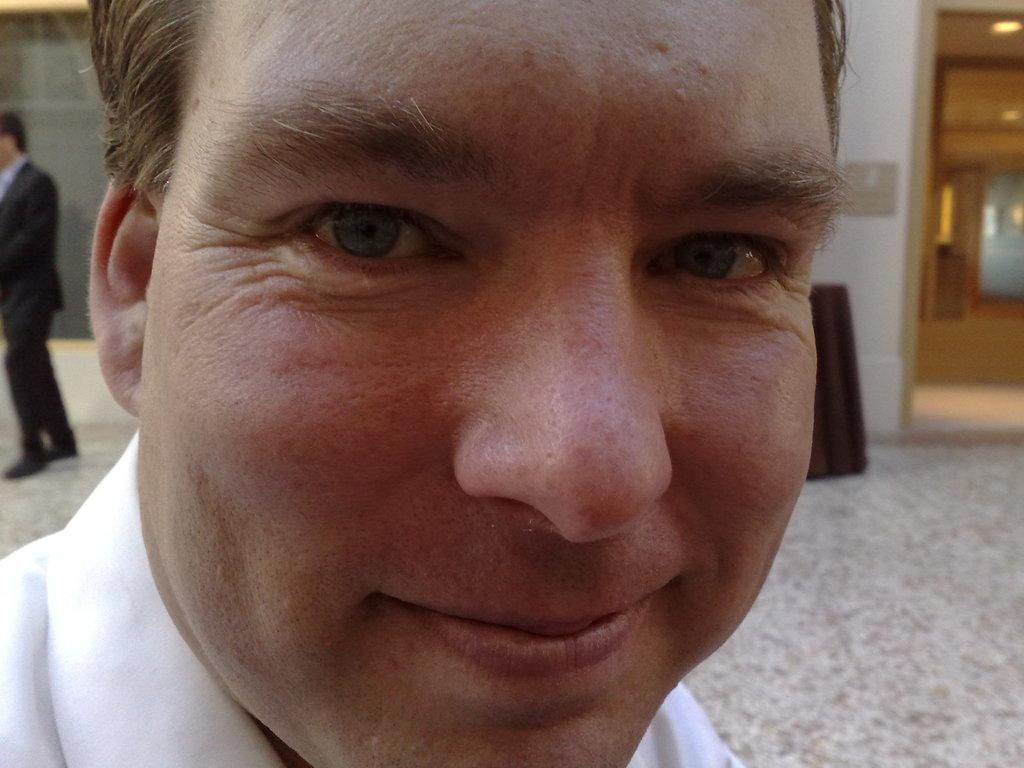Who is present in the image? There is a man in the image. What is the man doing in the image? The man is smiling in the image. Can you describe the background of the image? There is a person, a wall, lights, and some objects in the background of the image. What is the income of the girls in the image? There are no girls present in the image, so it is not possible to determine their income. 